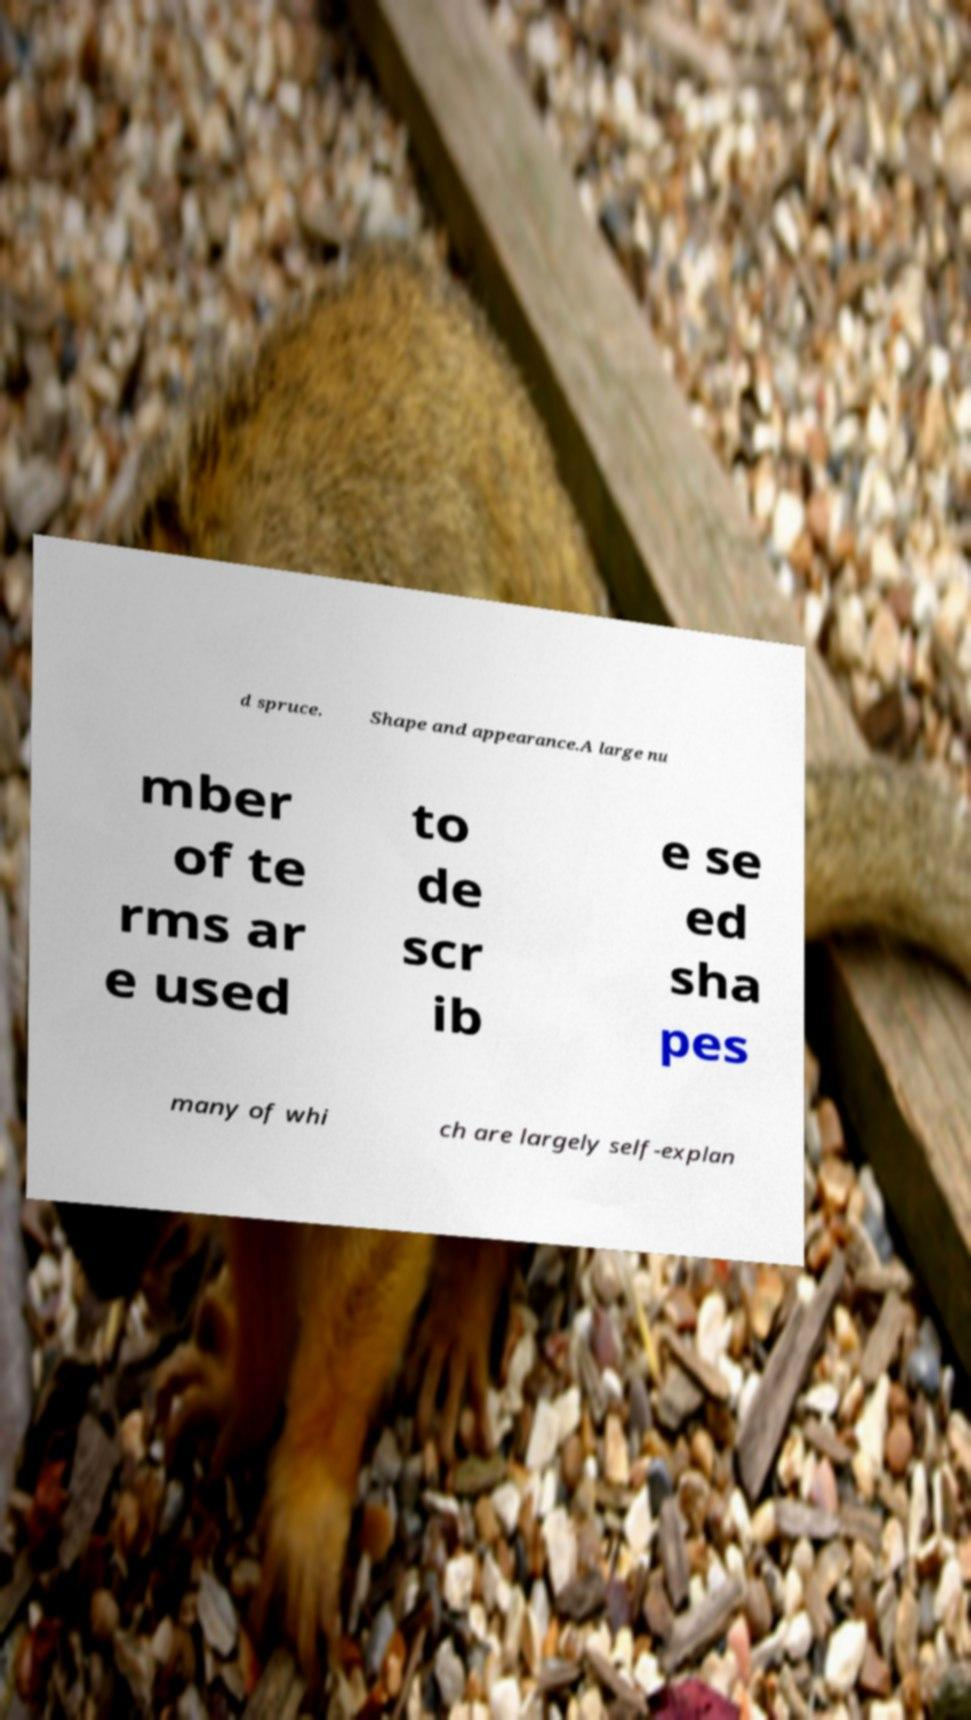Could you extract and type out the text from this image? d spruce. Shape and appearance.A large nu mber of te rms ar e used to de scr ib e se ed sha pes many of whi ch are largely self-explan 